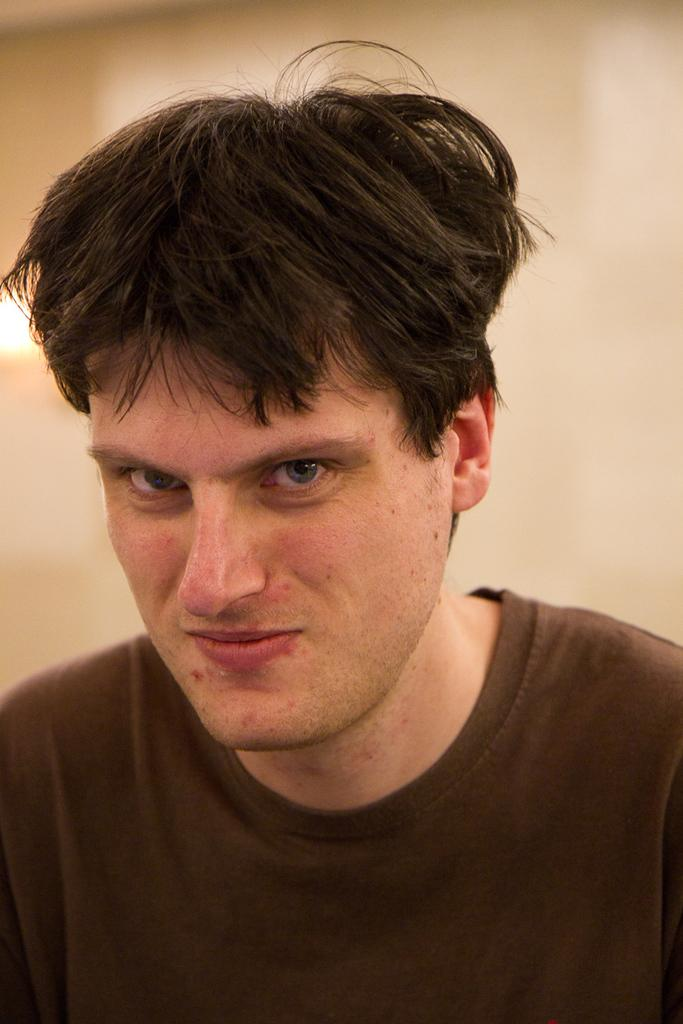Who or what is in the image? There is a person in the image. What is behind the person in the image? There is a wall behind the person. Can you describe the lighting in the image? There is a light on the left side of the image. What type of agreement was reached in the prison after the afterthought? There is no mention of an agreement, prison, or afterthought in the image. 